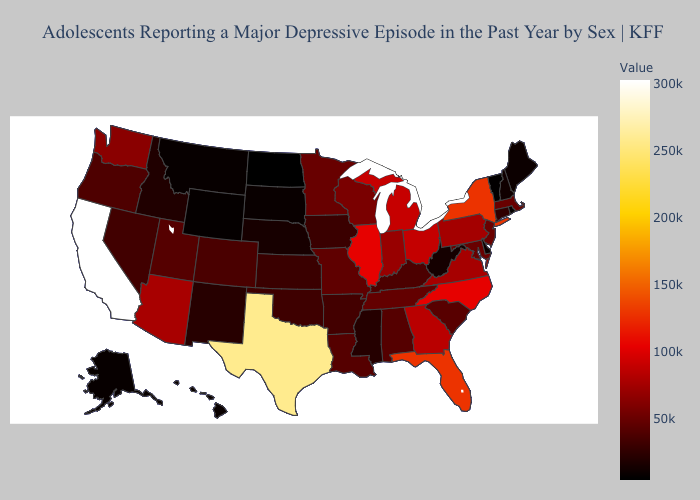Does Kentucky have the lowest value in the South?
Keep it brief. No. Among the states that border Utah , does New Mexico have the highest value?
Keep it brief. No. Does Texas have a lower value than Iowa?
Give a very brief answer. No. Does Texas have the highest value in the South?
Concise answer only. Yes. Does Idaho have the highest value in the USA?
Answer briefly. No. Among the states that border Oklahoma , which have the highest value?
Keep it brief. Texas. Does North Dakota have the lowest value in the USA?
Answer briefly. Yes. Is the legend a continuous bar?
Be succinct. Yes. Does Arkansas have the lowest value in the South?
Give a very brief answer. No. 